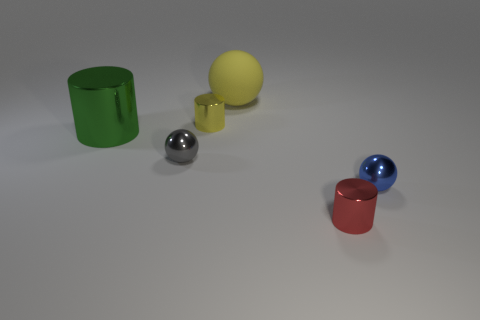Add 2 tiny yellow things. How many objects exist? 8 Add 2 big yellow metal cubes. How many big yellow metal cubes exist? 2 Subtract 0 cyan cylinders. How many objects are left? 6 Subtract all metallic balls. Subtract all blue balls. How many objects are left? 3 Add 6 metallic balls. How many metallic balls are left? 8 